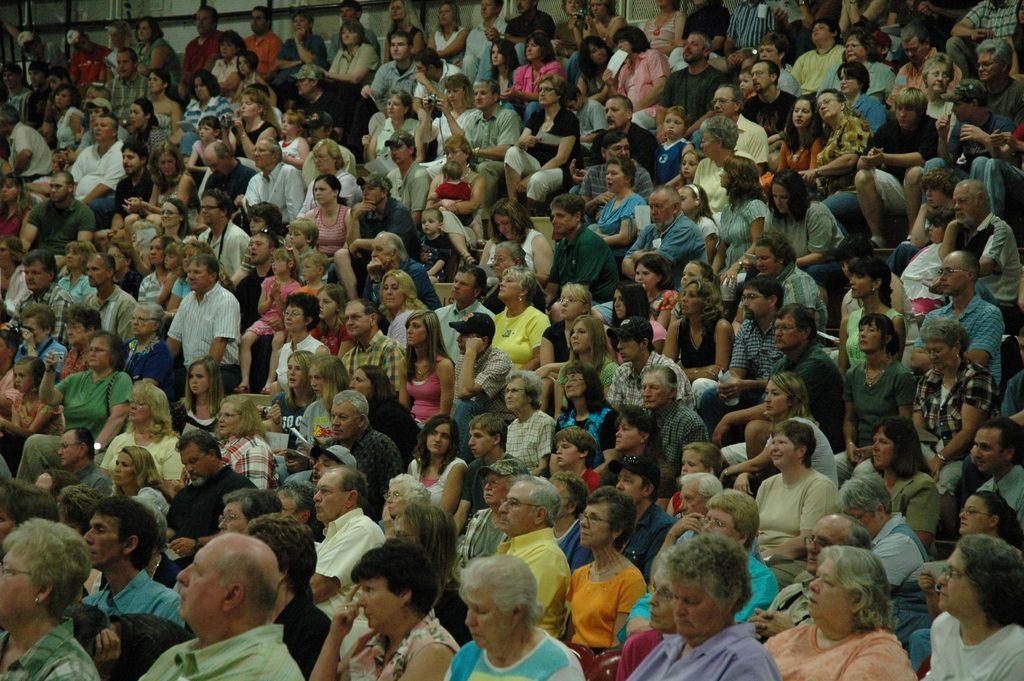Can you describe this image briefly? In the image few people are sitting and few people are sitting and holding some cameras. 